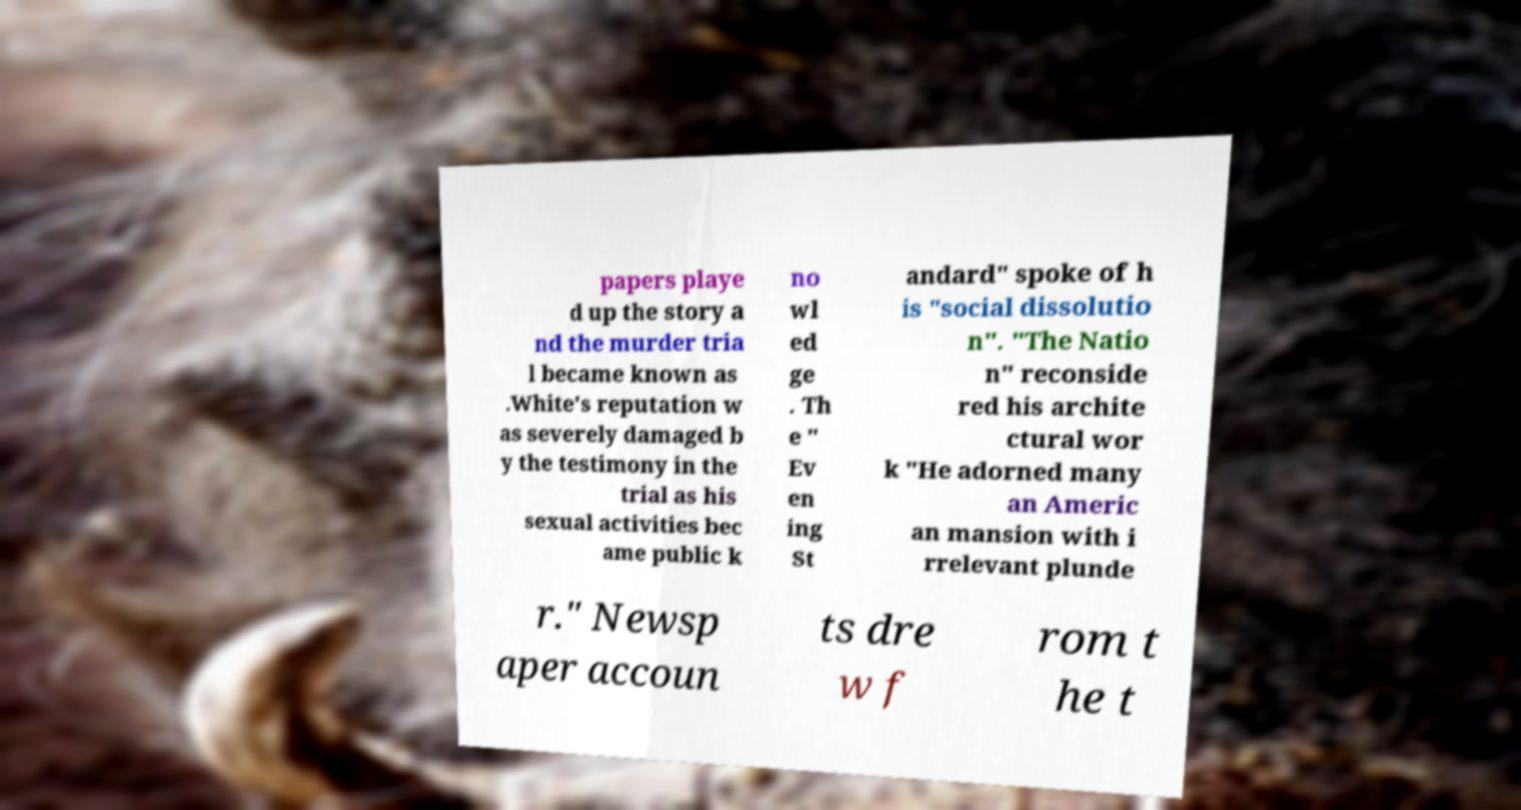There's text embedded in this image that I need extracted. Can you transcribe it verbatim? papers playe d up the story a nd the murder tria l became known as .White's reputation w as severely damaged b y the testimony in the trial as his sexual activities bec ame public k no wl ed ge . Th e " Ev en ing St andard" spoke of h is "social dissolutio n". "The Natio n" reconside red his archite ctural wor k "He adorned many an Americ an mansion with i rrelevant plunde r." Newsp aper accoun ts dre w f rom t he t 